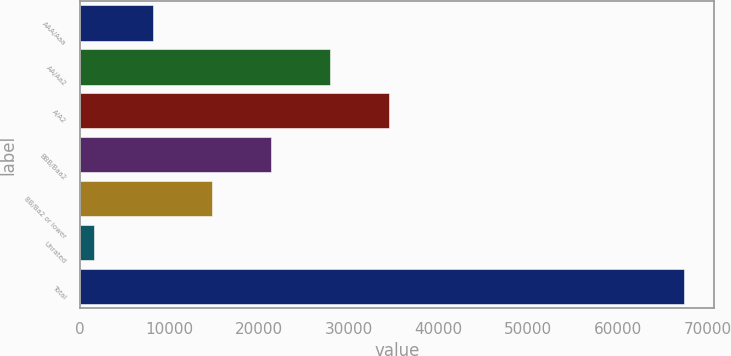Convert chart to OTSL. <chart><loc_0><loc_0><loc_500><loc_500><bar_chart><fcel>AAA/Aaa<fcel>AA/Aa2<fcel>A/A2<fcel>BBB/Baa2<fcel>BB/Ba2 or lower<fcel>Unrated<fcel>Total<nl><fcel>8178.6<fcel>27920.4<fcel>34501<fcel>21339.8<fcel>14759.2<fcel>1598<fcel>67404<nl></chart> 